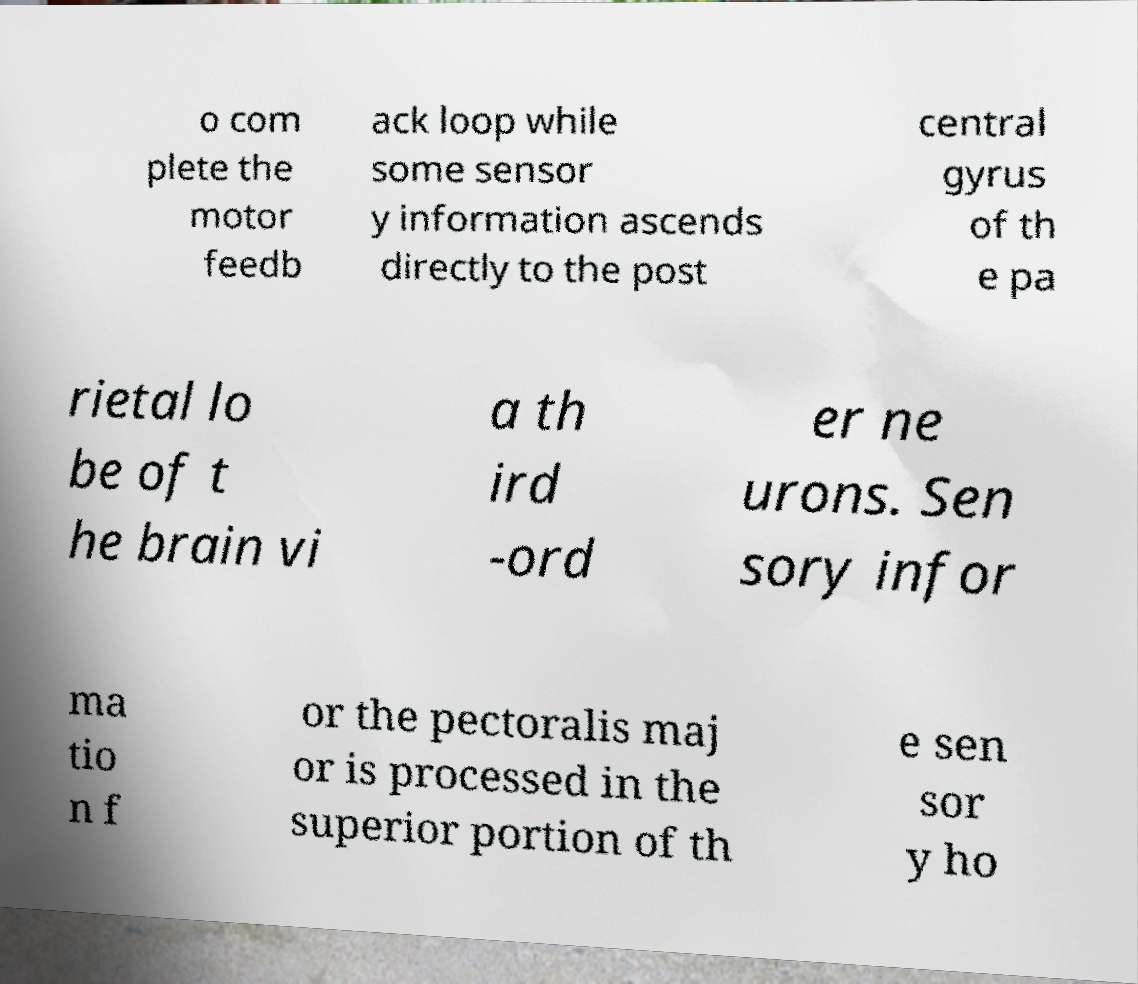There's text embedded in this image that I need extracted. Can you transcribe it verbatim? o com plete the motor feedb ack loop while some sensor y information ascends directly to the post central gyrus of th e pa rietal lo be of t he brain vi a th ird -ord er ne urons. Sen sory infor ma tio n f or the pectoralis maj or is processed in the superior portion of th e sen sor y ho 